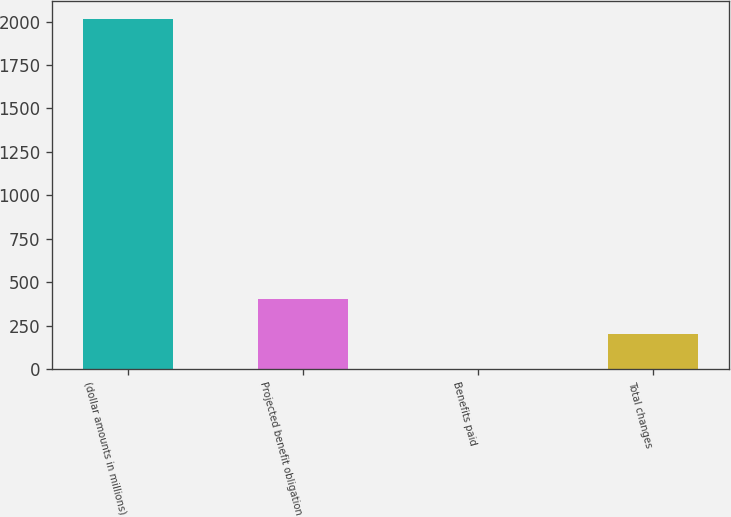<chart> <loc_0><loc_0><loc_500><loc_500><bar_chart><fcel>(dollar amounts in millions)<fcel>Projected benefit obligation<fcel>Benefits paid<fcel>Total changes<nl><fcel>2017<fcel>405<fcel>2<fcel>203.5<nl></chart> 